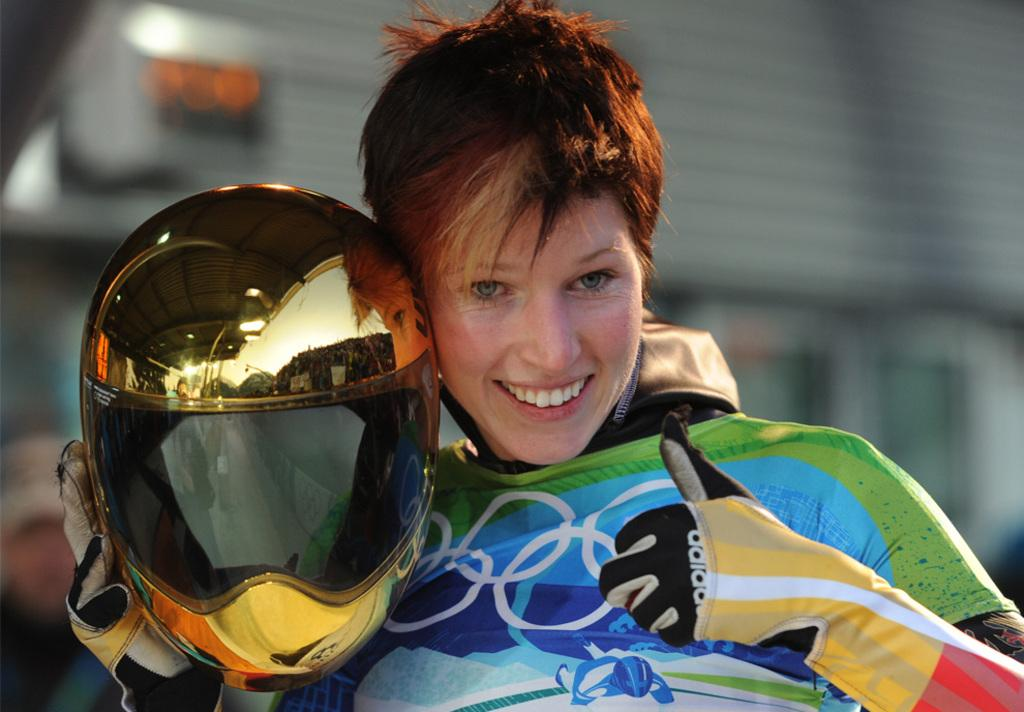What can be seen in the image? There is a person in the image. What is the person wearing? The person is wearing gloves. What object is the person holding? The person is holding a helmet in their hand. Can you describe the background of the image? The background of the image is blurry. Can you see any bees in the image? There are no bees present in the image. Does the person in the image have a bite mark on their arm? There is no indication of a bite mark on the person's arm in the image. 